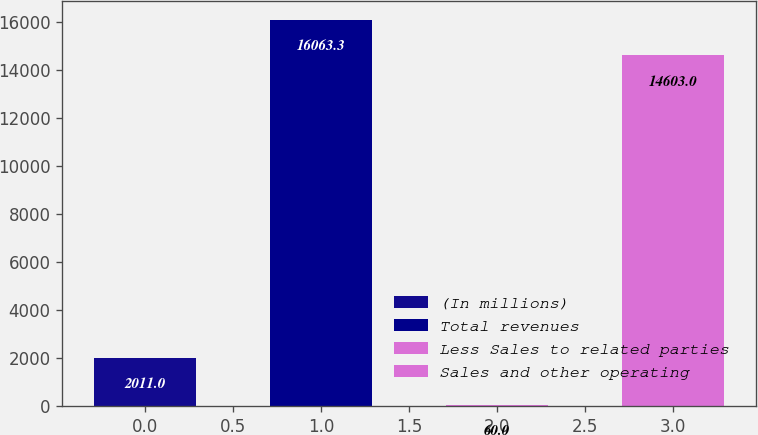Convert chart to OTSL. <chart><loc_0><loc_0><loc_500><loc_500><bar_chart><fcel>(In millions)<fcel>Total revenues<fcel>Less Sales to related parties<fcel>Sales and other operating<nl><fcel>2011<fcel>16063.3<fcel>60<fcel>14603<nl></chart> 